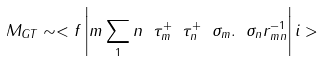Convert formula to latex. <formula><loc_0><loc_0><loc_500><loc_500>M _ { G T } \sim < f \left | m \sum _ { 1 } n \ \tau ^ { + } _ { m } \ \tau ^ { + } _ { n } \ \sigma _ { m } . \ \sigma _ { n } r ^ { - 1 } _ { m n } \right | i ></formula> 